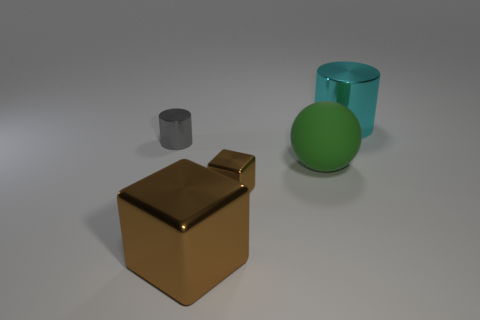How many gray cylinders are there? There is one gray cylinder in the image, positioned between a golden cube and a teal cylinder. 